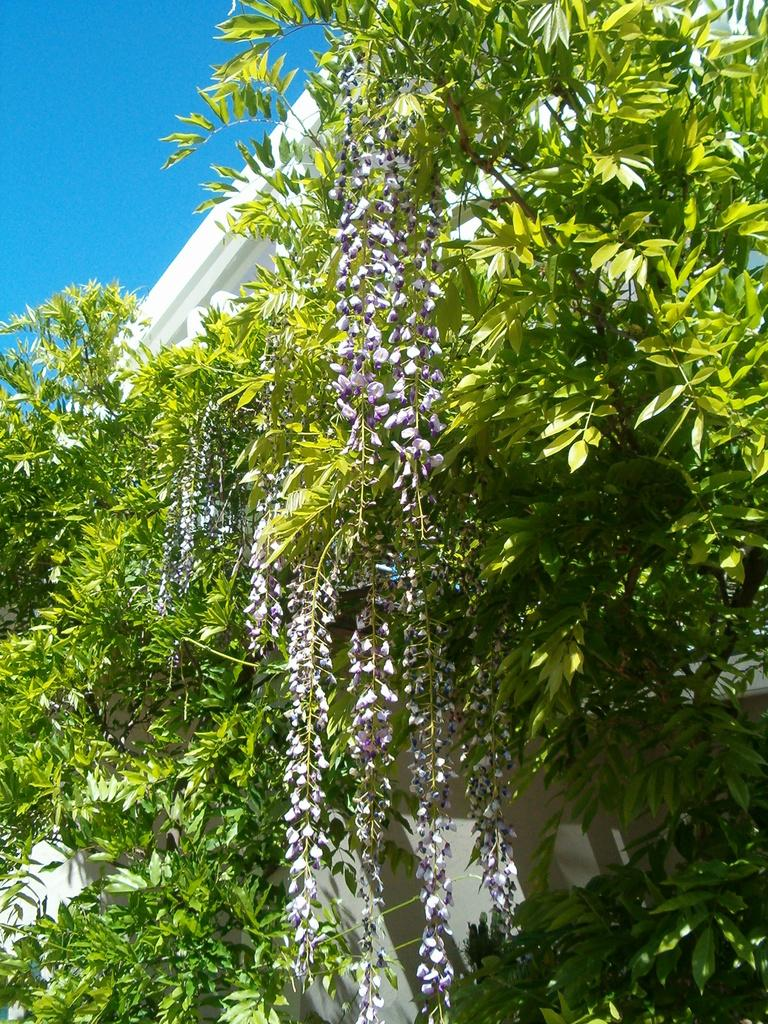What type of vegetation is present in the front of the image? There are plants in the front of the image. What type of structure can be seen in the image? There is a building in the image. What is the color of the building? The building is white in color. Can you see any stoves or spades in the image? No, there are no stoves or spades present in the image. Is there any blood visible in the image? No, there is no blood visible in the image. 